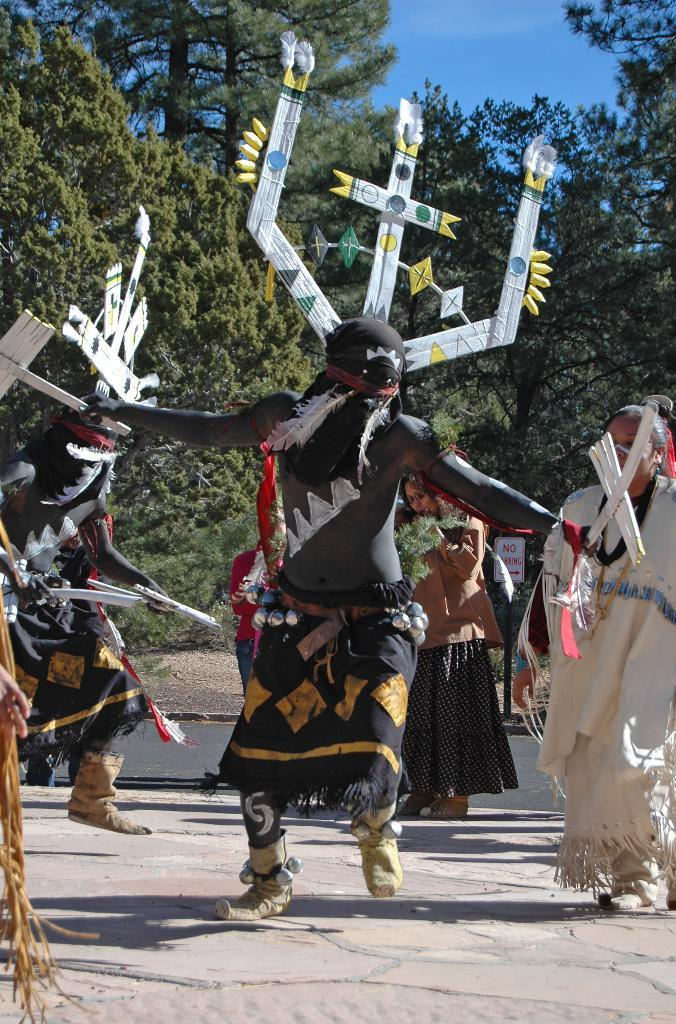How many persons are in fancy dresses in the image? There are two persons in fancy dresses in the image. What are the people in the image doing? The people are standing in the image. What can be seen in the image besides the people? There is a board with a pole in the image. What is visible in the background of the image? Trees and the sky are visible in the background of the image. What type of stone is being used to turn the page in the image? There is no stone or page present in the image; it features two persons in fancy dresses, people standing, a board with a pole, trees, and the sky in the background. 